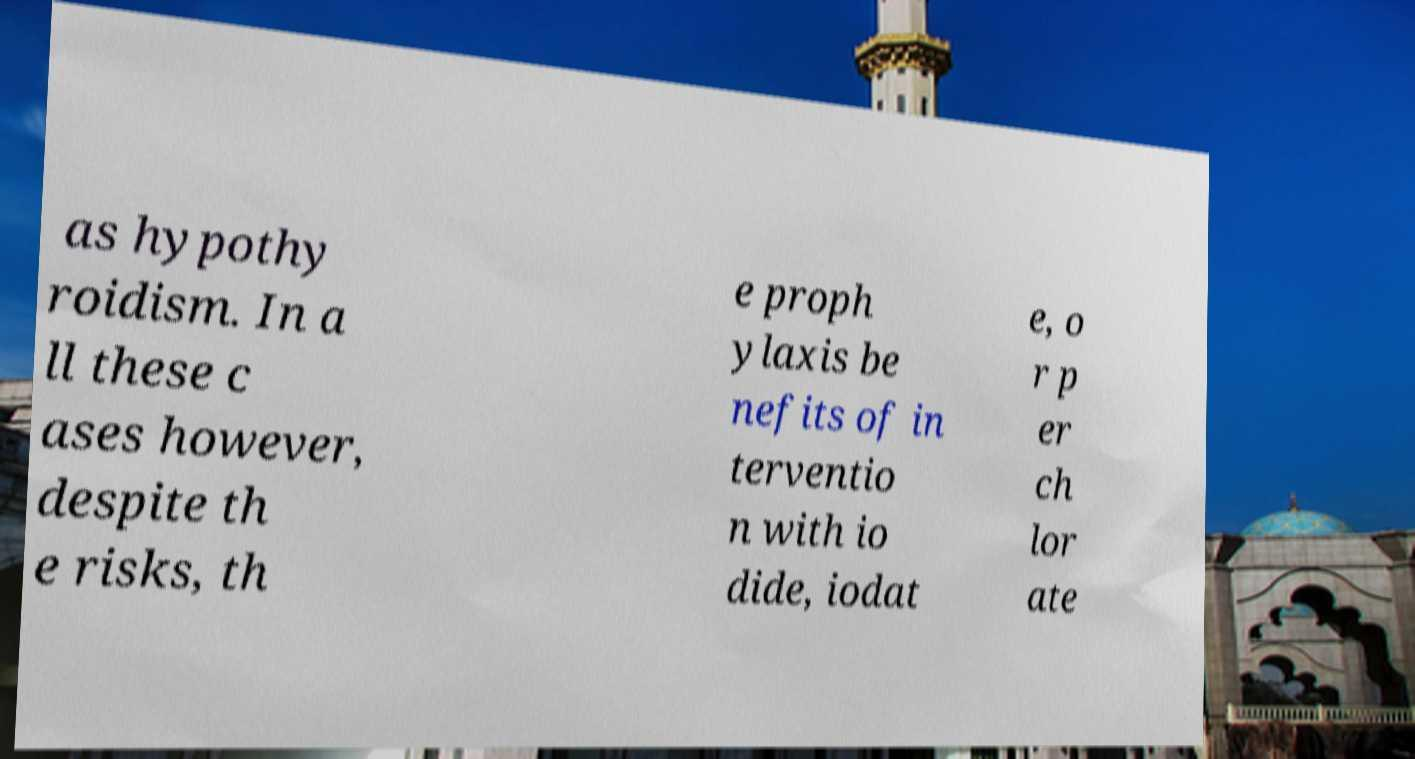Please read and relay the text visible in this image. What does it say? as hypothy roidism. In a ll these c ases however, despite th e risks, th e proph ylaxis be nefits of in terventio n with io dide, iodat e, o r p er ch lor ate 